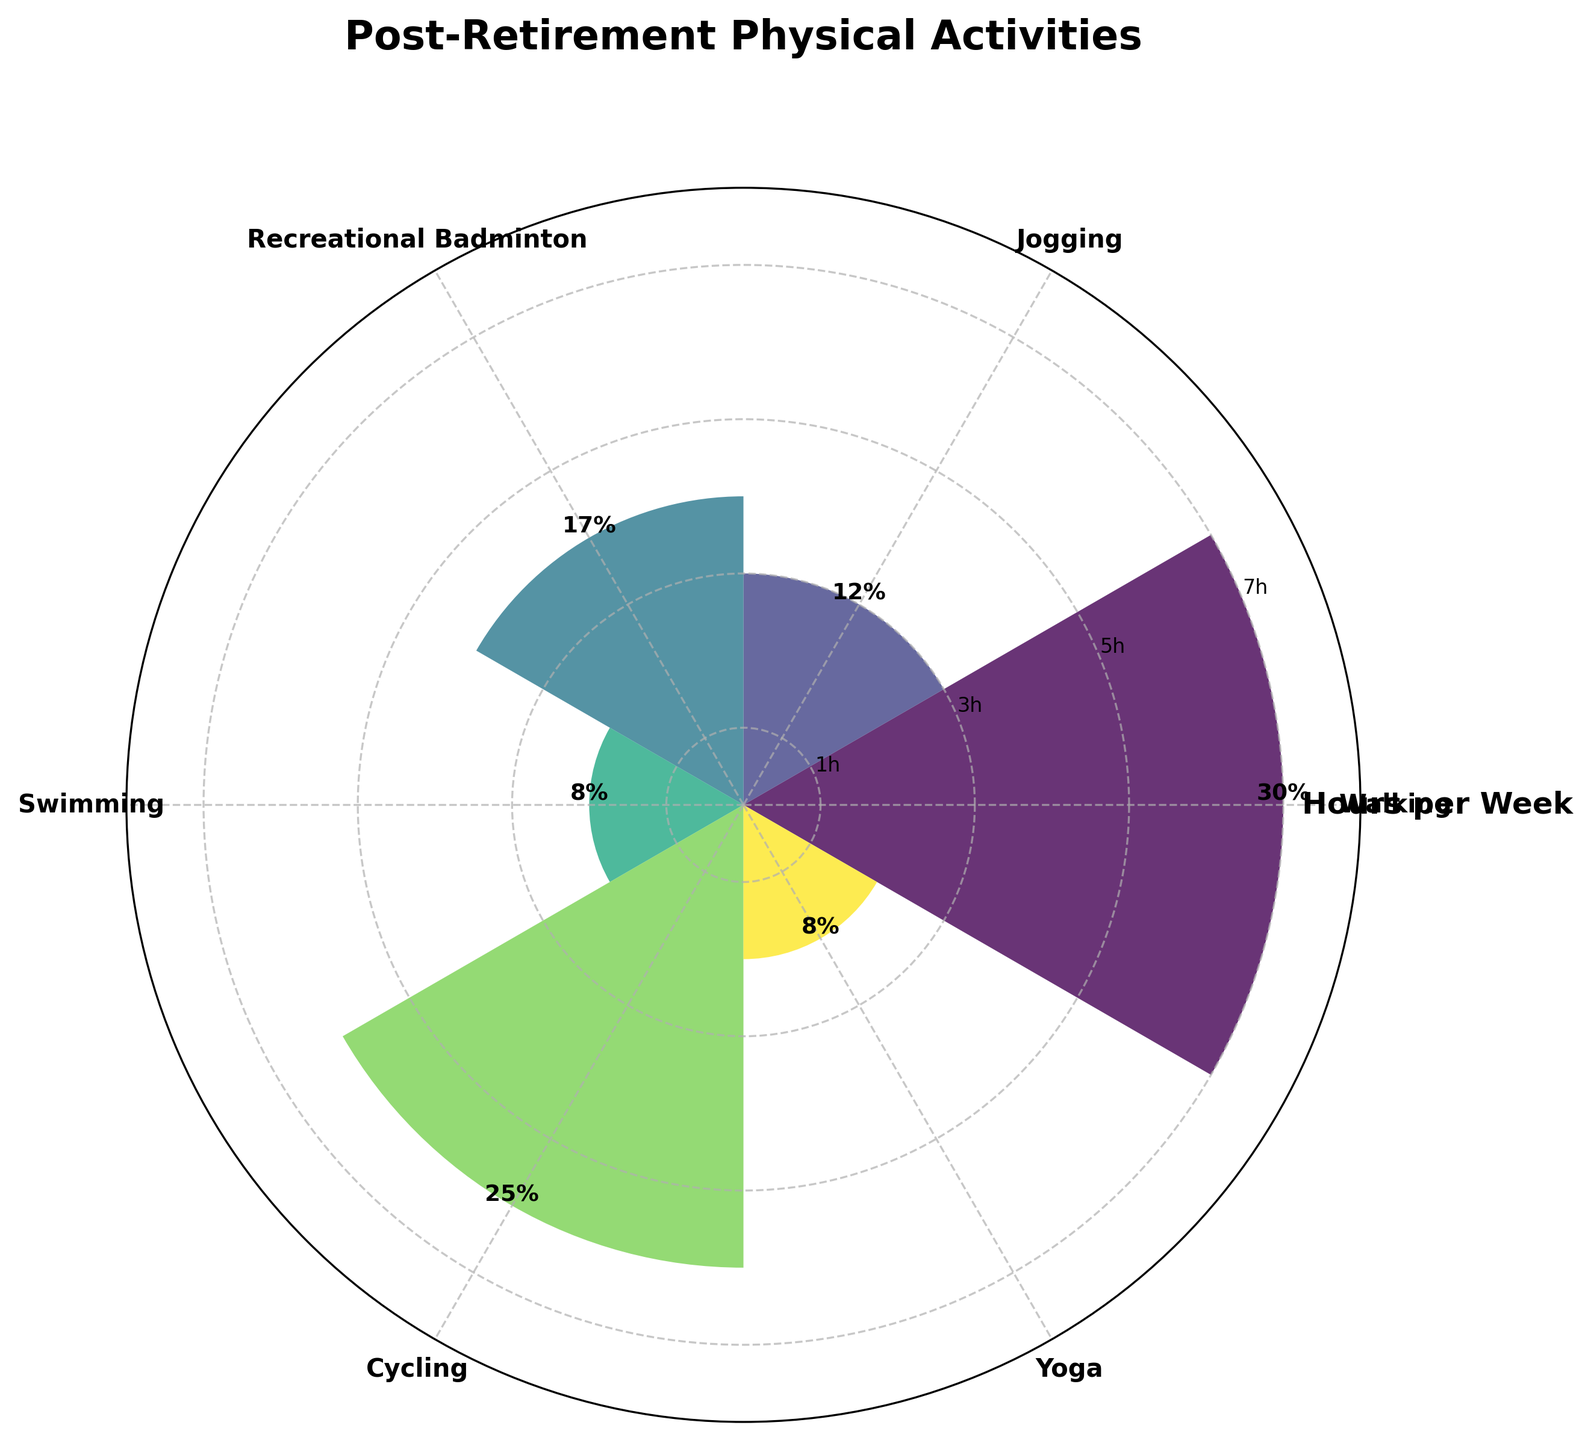1. What is the title of the figure? The title of the figure is located at the top, which is a standard for most charts and graphs. By looking at the top of the rose chart, we can see the title "Post-Retirement Physical Activities".
Answer: Post-Retirement Physical Activities 2. How many activities are displayed in the figure? To determine the number of activities, count the labels on the x-axis around the polar chart. There are six labels, each representing a different activity.
Answer: 6 3. Which activity accounts for the highest number of hours per week? Observe the bars in the polar chart and find the tallest bar. The tallest bar is labeled "Walking". Therefore, Walking accounts for the highest number of hours per week.
Answer: Walking 4. What percentage of total active hours is dedicated to Swimming? Refer to the text label associated with the bar for Swimming. The label indicates that Swimming accounts for 8% of total active hours.
Answer: 8% 5. How many hours per week are spent on Yoga? Look at the length of the bar associated with Yoga. The bar indicates that 2 hours per week are spent on Yoga.
Answer: 2 hours 6. Which activity takes up more time per week: Cycling or Jogging? Compare the lengths of the bars for Cycling and Jogging. The bar for Cycling is longer (6 hours) compared to Jogging (3 hours). Therefore, Cycling takes up more time per week than Jogging.
Answer: Cycling 7. What is the total number of hours spent on activities per week? Add up the hours per week for all activities: Walking (7) + Jogging (3) + Recreational Badminton (4) + Swimming (2) + Cycling (6) + Yoga (2). The sum is 24 hours per week.
Answer: 24 hours 8. What is the average percentage of total active hours across all activities? Add up the percentages of total active hours for all activities: 30% (Walking) + 12% (Jogging) + 17% (Recreational Badminton) + 8% (Swimming) + 25% (Cycling) + 8% (Yoga). The sum is 100%. Divide this by the number of activities (6) to find the average: 100 / 6.
Answer: 16.67% 9. Which activities have an equal percentage of total active hours, and what is that percentage? By looking at the label with percentage values around the chart, we can see that both Swimming and Yoga have the same percentage of total active hours, which is 8%.
Answer: Swimming and Yoga, 8% 10. If you add the hours spent on Walking and Cycling, how does the total compare to the hours spent on the remaining activities? First, calculate the total hours for Walking (7) and Cycling (6): 7 + 6 = 13 hours. Then, calculate the total hours for the remaining activities: Jogging (3) + Recreational Badminton (4) + Swimming (2) + Yoga (2): 3 + 4 + 2 + 2 = 11 hours. Compare the two totals, 13 hours is greater than 11 hours.
Answer: 13 hours is greater than 11 hours 